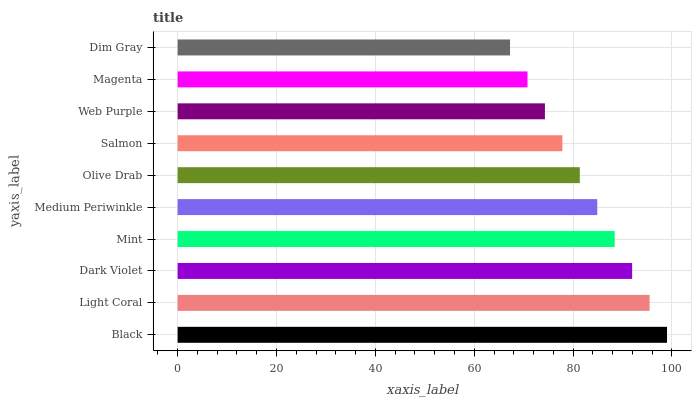Is Dim Gray the minimum?
Answer yes or no. Yes. Is Black the maximum?
Answer yes or no. Yes. Is Light Coral the minimum?
Answer yes or no. No. Is Light Coral the maximum?
Answer yes or no. No. Is Black greater than Light Coral?
Answer yes or no. Yes. Is Light Coral less than Black?
Answer yes or no. Yes. Is Light Coral greater than Black?
Answer yes or no. No. Is Black less than Light Coral?
Answer yes or no. No. Is Medium Periwinkle the high median?
Answer yes or no. Yes. Is Olive Drab the low median?
Answer yes or no. Yes. Is Dim Gray the high median?
Answer yes or no. No. Is Mint the low median?
Answer yes or no. No. 